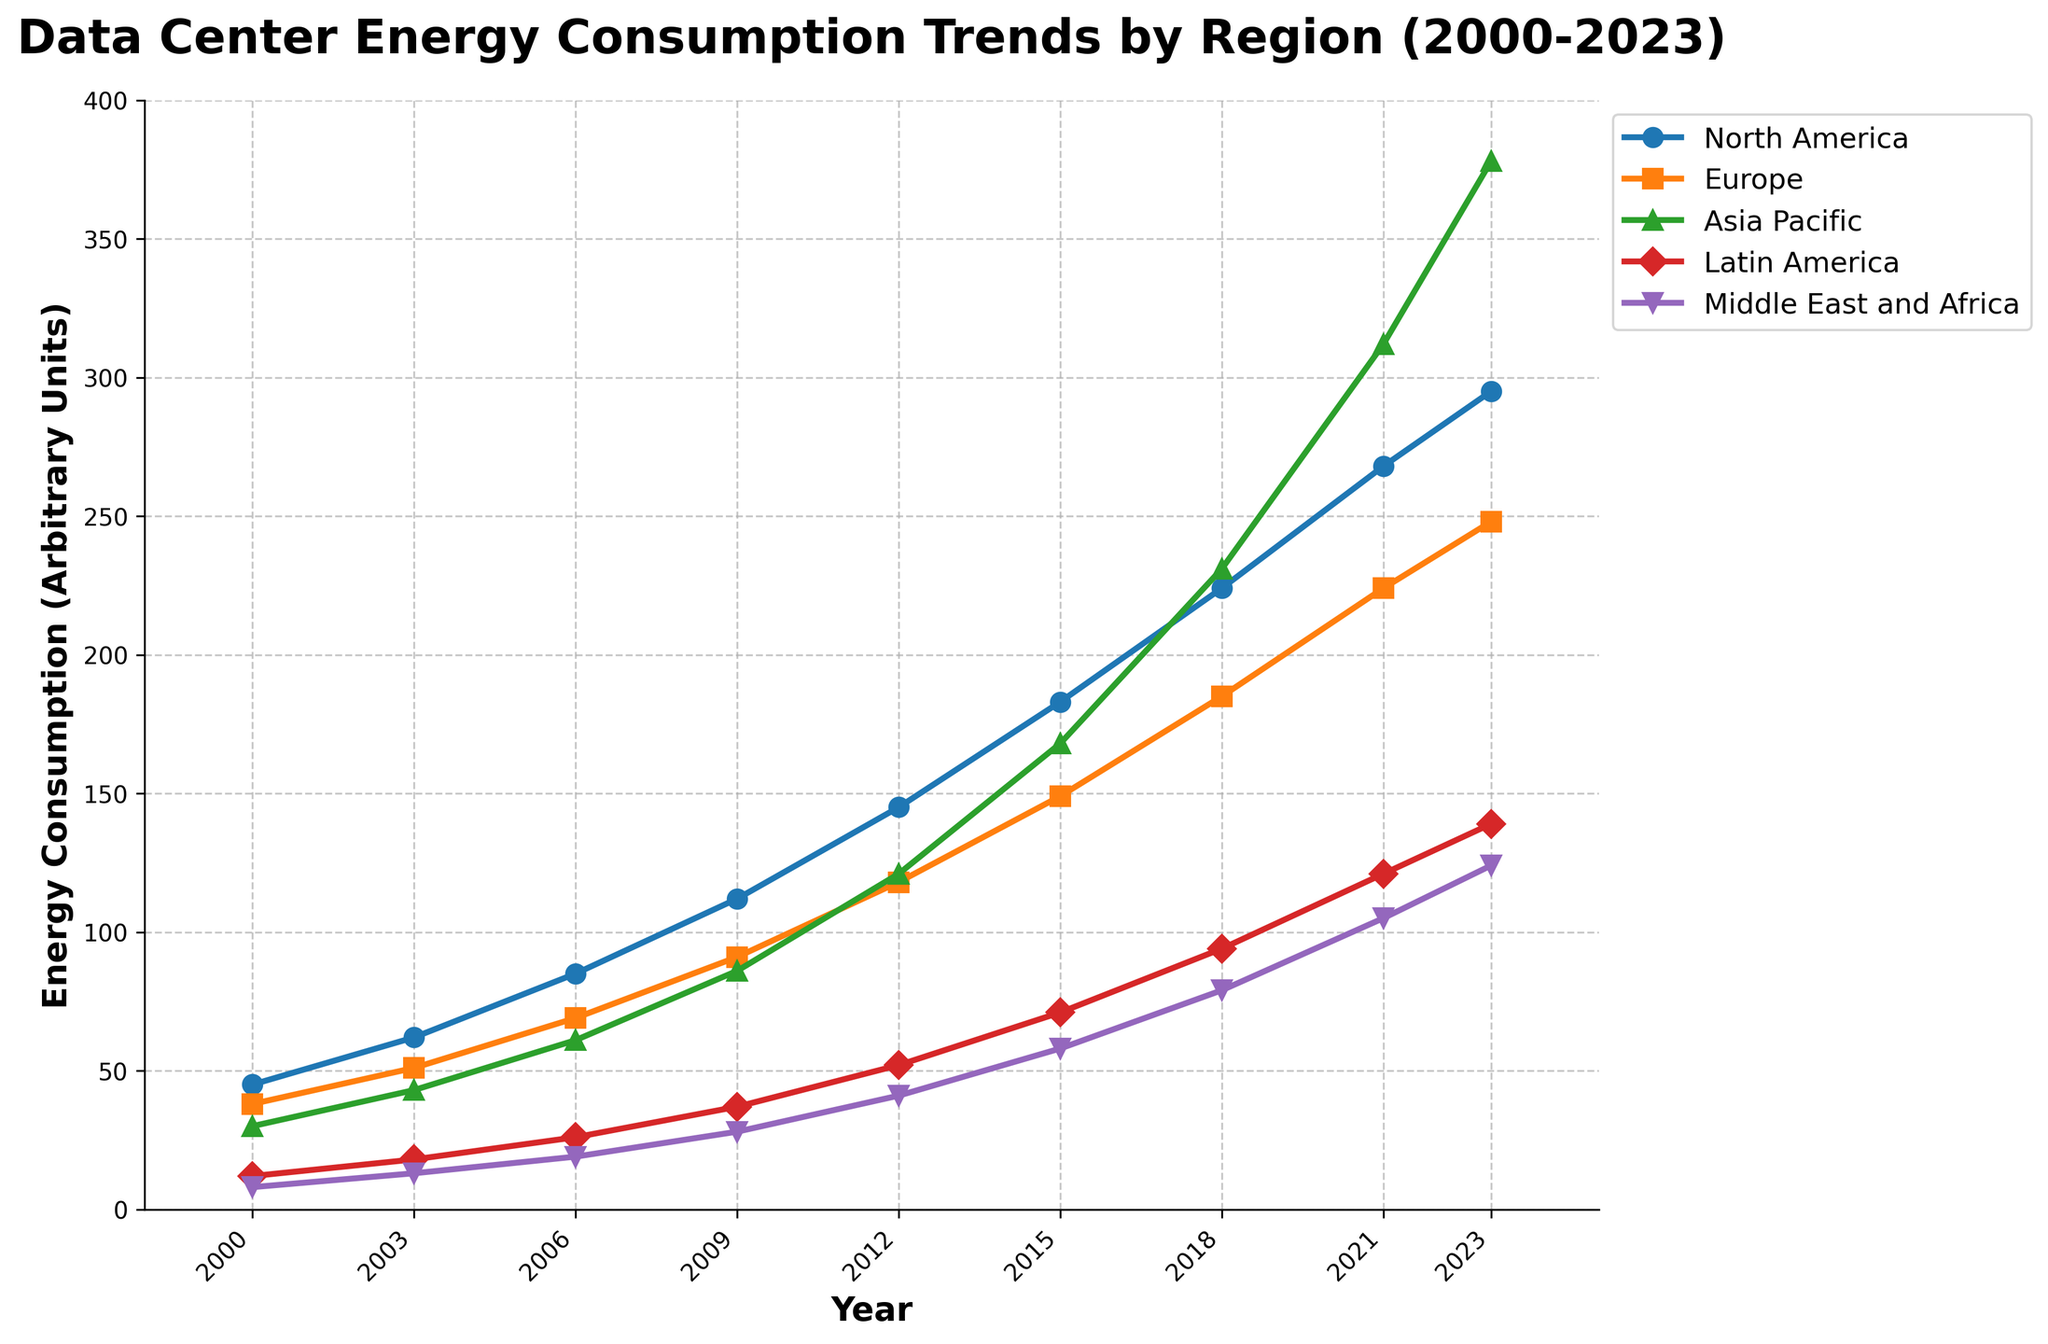What's the general trend of energy consumption in the Asia Pacific region between 2000 and 2023? From the figure, you can see the data points for the Asia Pacific region plotted on the Y-axis against the years on the X-axis. The energy consumption increases from 30 in 2000 to 378 in 2023. This indicates a consistently increasing trend.
Answer: Increasing Which region had the lowest energy consumption in 2000, and what was the value? By comparing the plotted energy consumption values for each region in 2000, you see that the Middle East and Africa had the lowest value of 8.
Answer: Middle East and Africa, 8 In which year did North America surpass 200 in energy consumption? Observing the values on the plot associated with North America, you see that it surpasses 200 between 2015 and 2018. The specific value in 2018 is shown as 224, so it surpassed 200 in 2018.
Answer: 2018 By how much did energy consumption in Europe increase from 2000 to 2023? Find the energy consumption values for Europe in 2000 and 2023 from the plot, which are 38 and 248 respectively. Subtract the 2000 value from the 2023 value: 248 - 38 = 210.
Answer: 210 Which region had the steepest increase in energy consumption from 2000 to 2023? Observing the trend lines for all regions, Asia Pacific shows the steepest increase, going from 30 in 2000 to 378 in 2023, an increase of 348 units.
Answer: Asia Pacific How does the energy consumption in Latin America in 2023 compare to that in 2012? From the plot, Latin America's energy consumption in 2012 is 52 and in 2023 is 139. Comparing these numbers, we see an increase of 139 - 52 = 87 units.
Answer: Increased by 87 Which regions had energy consumptions greater than 100 in 2021? Look at the plot for each region's energy consumption in 2021. North America had 268, Europe had 224, Asia Pacific had 312, Latin America had 121, and the Middle East and Africa had 105. All these values are greater than 100.
Answer: All regions What is the combined energy consumption of Europe and the Middle East and Africa in 2023? Find the values for Europe and the Middle East and Africa for 2023, which are 248 and 124 respectively. Sum these values: 248 + 124 = 372.
Answer: 372 How much did energy consumption in North America increase from 2009 to 2015? Find North America's energy consumption values for 2009 and 2015 from the plot, which are 112 and 183 respectively. Calculate the difference: 183 - 112 = 71.
Answer: 71 